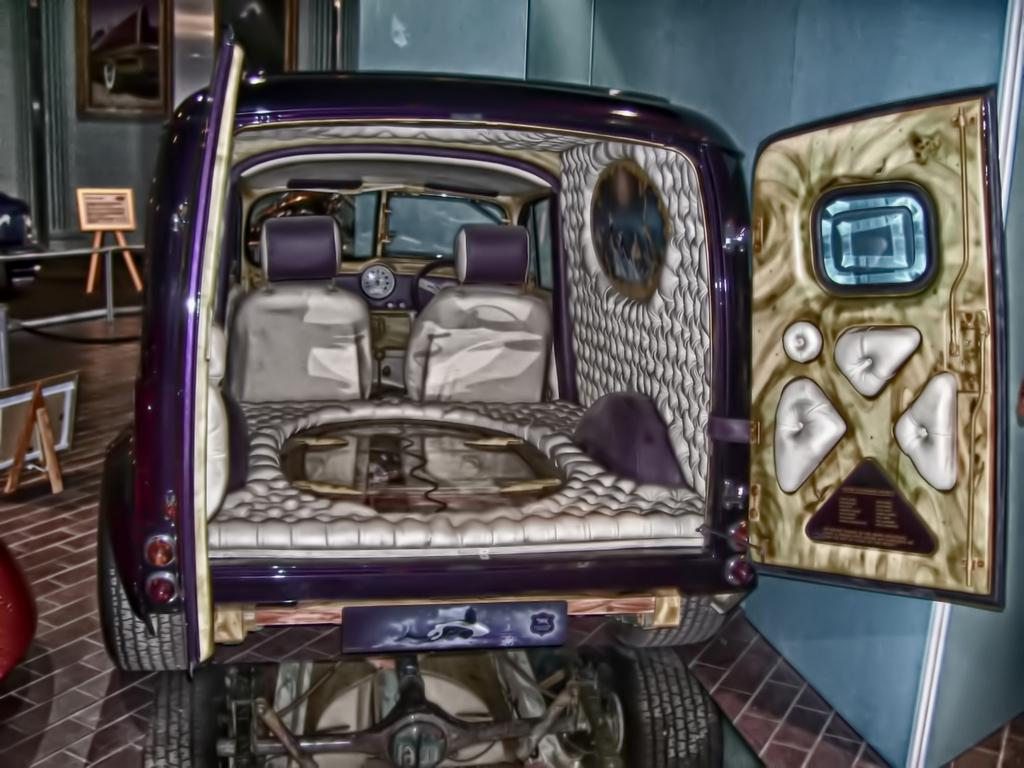What color is the vehicle in the image? The vehicle in the image is purple. What is the state of the vehicle's doors? The vehicle's doors are open. What can be seen in the background of the image? There is a wall in the image. What is on the wall in the image? The wall has two photo frames. How many ants are crawling on the vehicle in the image? There are no ants visible in the image; the focus is on the vehicle and its open doors. 